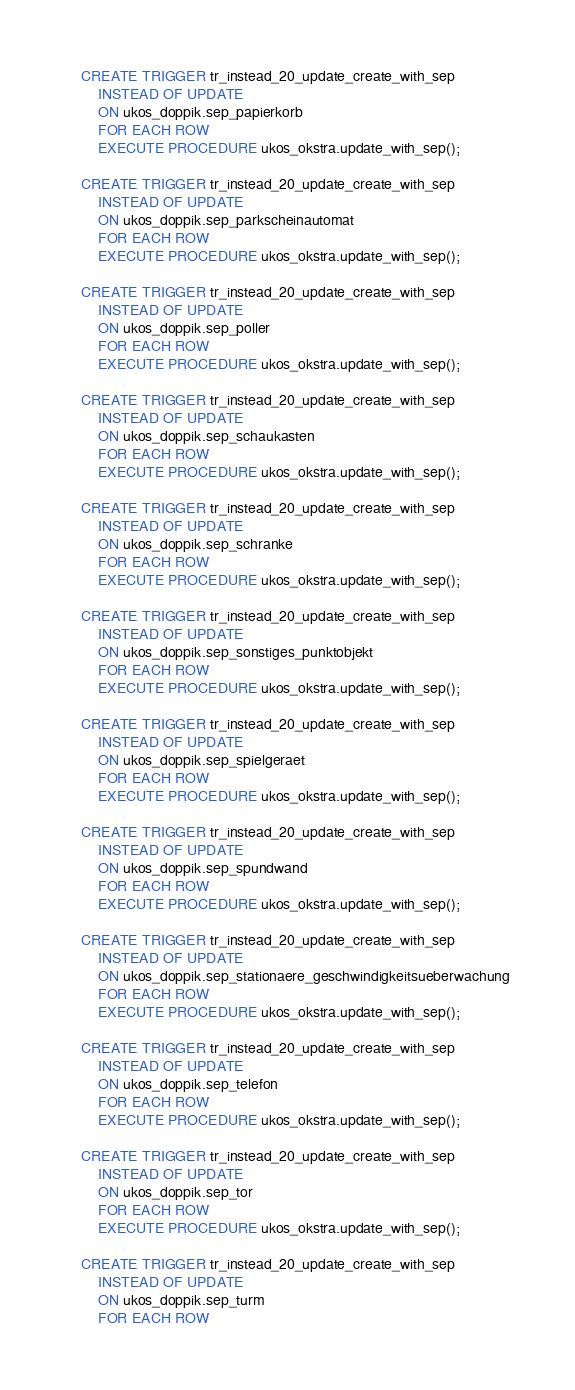<code> <loc_0><loc_0><loc_500><loc_500><_SQL_>	CREATE TRIGGER tr_instead_20_update_create_with_sep
		INSTEAD OF UPDATE 
		ON ukos_doppik.sep_papierkorb
		FOR EACH ROW
		EXECUTE PROCEDURE ukos_okstra.update_with_sep();

	CREATE TRIGGER tr_instead_20_update_create_with_sep
		INSTEAD OF UPDATE 
		ON ukos_doppik.sep_parkscheinautomat
		FOR EACH ROW
		EXECUTE PROCEDURE ukos_okstra.update_with_sep();

	CREATE TRIGGER tr_instead_20_update_create_with_sep
		INSTEAD OF UPDATE 
		ON ukos_doppik.sep_poller
		FOR EACH ROW
		EXECUTE PROCEDURE ukos_okstra.update_with_sep();

	CREATE TRIGGER tr_instead_20_update_create_with_sep
		INSTEAD OF UPDATE 
		ON ukos_doppik.sep_schaukasten
		FOR EACH ROW
		EXECUTE PROCEDURE ukos_okstra.update_with_sep();

	CREATE TRIGGER tr_instead_20_update_create_with_sep
		INSTEAD OF UPDATE 
		ON ukos_doppik.sep_schranke
		FOR EACH ROW
		EXECUTE PROCEDURE ukos_okstra.update_with_sep();

	CREATE TRIGGER tr_instead_20_update_create_with_sep
		INSTEAD OF UPDATE 
		ON ukos_doppik.sep_sonstiges_punktobjekt
		FOR EACH ROW
		EXECUTE PROCEDURE ukos_okstra.update_with_sep();

	CREATE TRIGGER tr_instead_20_update_create_with_sep
		INSTEAD OF UPDATE 
		ON ukos_doppik.sep_spielgeraet
		FOR EACH ROW
		EXECUTE PROCEDURE ukos_okstra.update_with_sep();

	CREATE TRIGGER tr_instead_20_update_create_with_sep
		INSTEAD OF UPDATE 
		ON ukos_doppik.sep_spundwand
		FOR EACH ROW
		EXECUTE PROCEDURE ukos_okstra.update_with_sep();

	CREATE TRIGGER tr_instead_20_update_create_with_sep
		INSTEAD OF UPDATE 
		ON ukos_doppik.sep_stationaere_geschwindigkeitsueberwachung
		FOR EACH ROW
		EXECUTE PROCEDURE ukos_okstra.update_with_sep();

	CREATE TRIGGER tr_instead_20_update_create_with_sep
		INSTEAD OF UPDATE 
		ON ukos_doppik.sep_telefon
		FOR EACH ROW
		EXECUTE PROCEDURE ukos_okstra.update_with_sep();

	CREATE TRIGGER tr_instead_20_update_create_with_sep
		INSTEAD OF UPDATE 
		ON ukos_doppik.sep_tor
		FOR EACH ROW
		EXECUTE PROCEDURE ukos_okstra.update_with_sep();

	CREATE TRIGGER tr_instead_20_update_create_with_sep
		INSTEAD OF UPDATE 
		ON ukos_doppik.sep_turm
		FOR EACH ROW</code> 